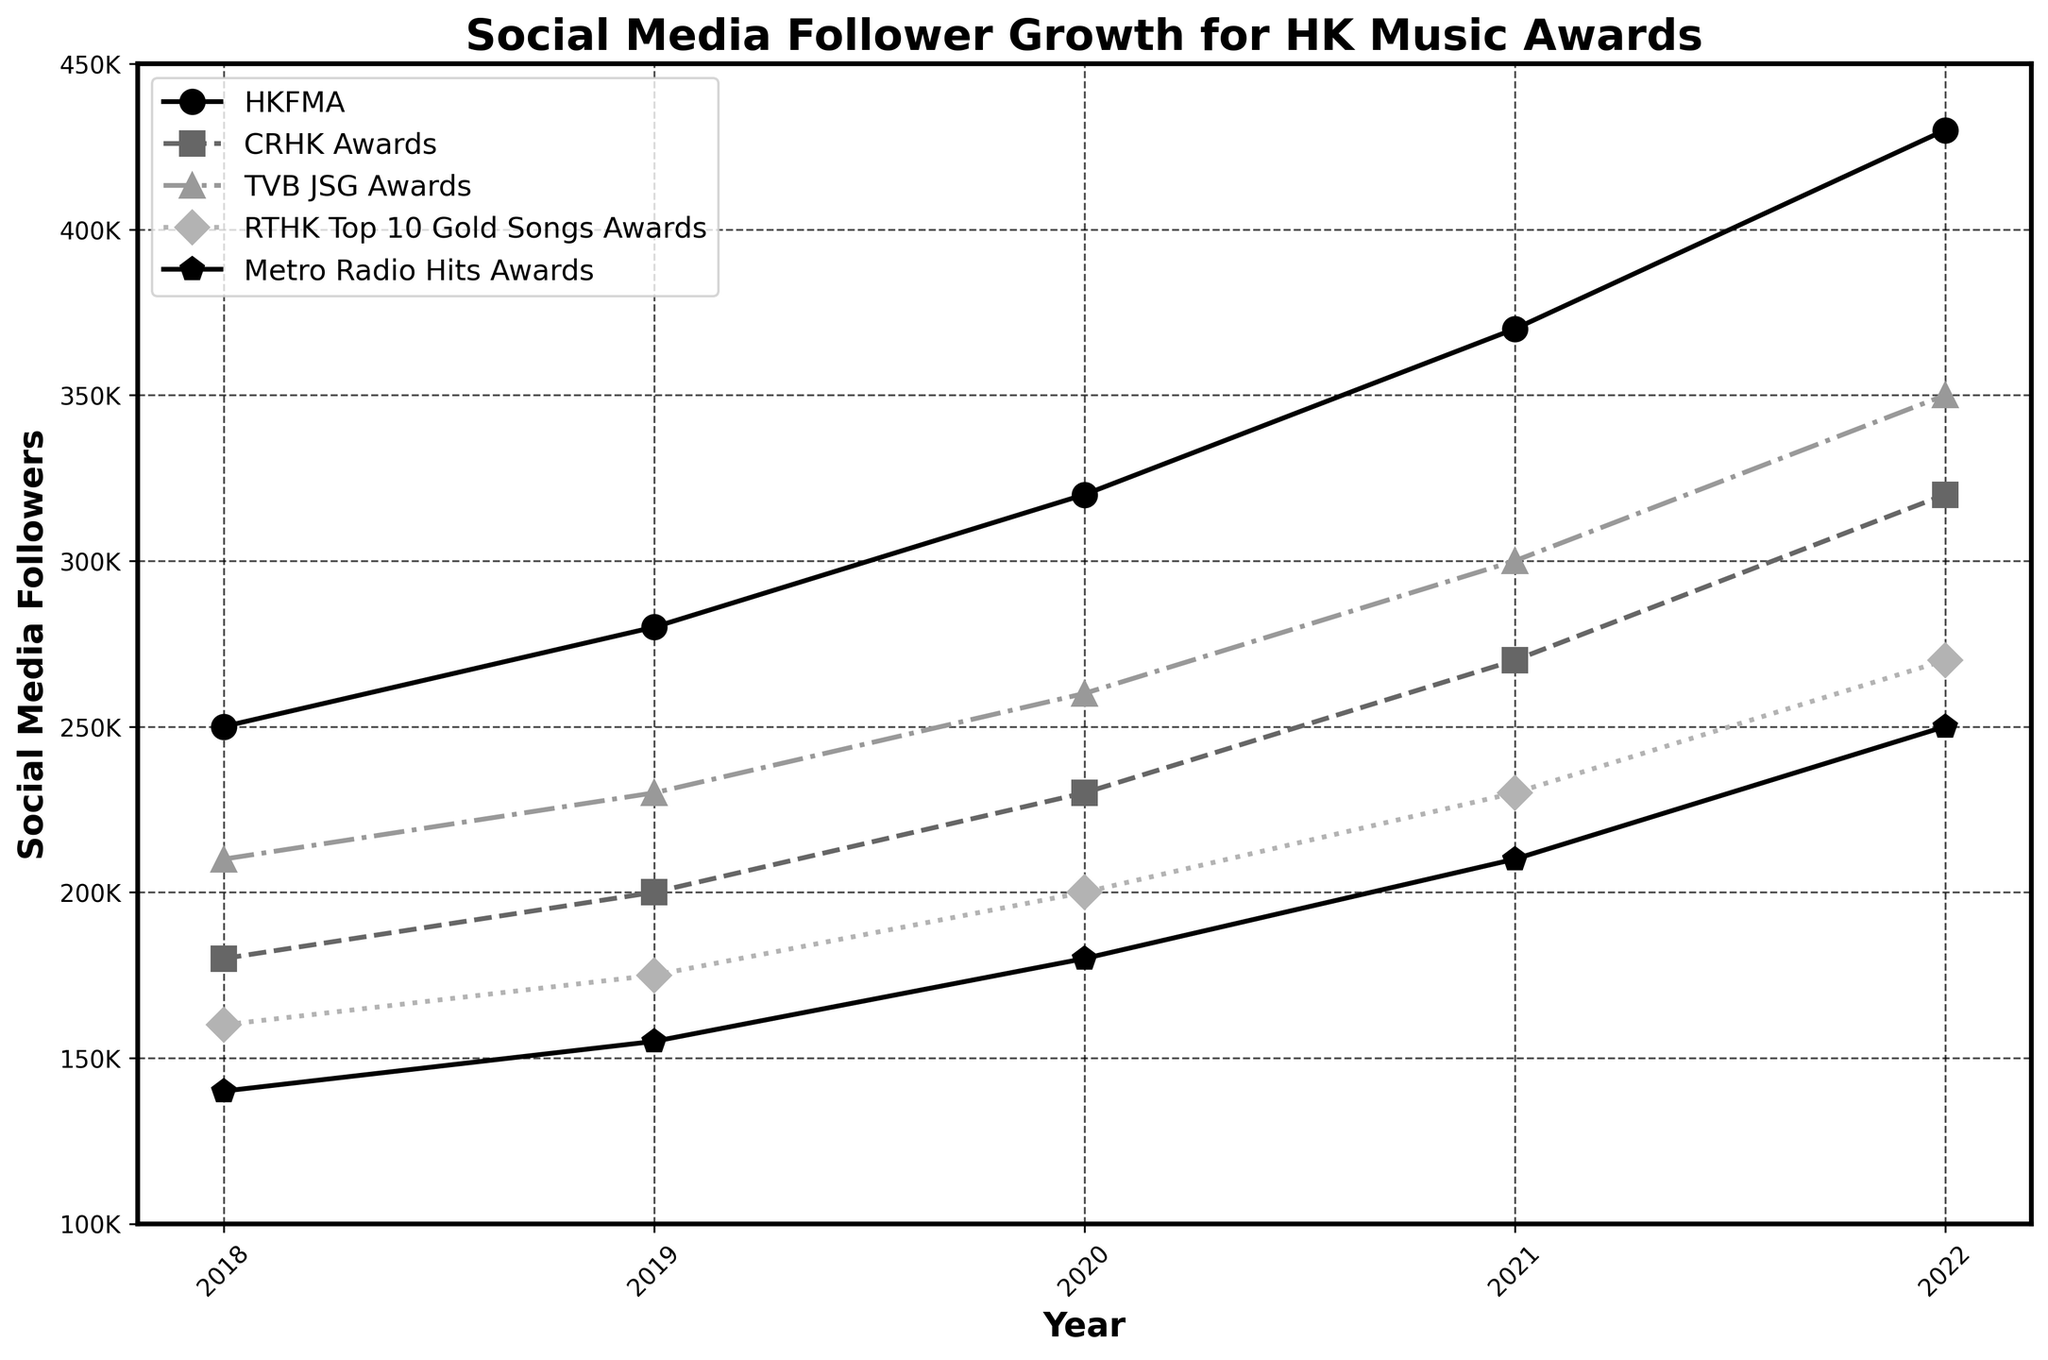Which music award show had the largest number of social media followers in 2021? Look at the 2021 data points on the graph and identify the highest line. The HKFMA had the highest follower count in 2021.
Answer: HKFMA Which award show saw the greatest increase in followers from 2018 to 2022? Calculate the difference in follower count from 2018 to 2022 for each award show. HKFMA increased by 430,000 - 250,000 = 180,000, CRHK Awards by 320,000 - 180,000 = 140,000, TVB JSG Awards by 350,000 - 210,000 = 140,000, RTHK Top 10 Gold Songs Awards by 270,000 - 160,000 = 110,000, and Metro Radio Hits Awards by 250,000 - 140,000 = 110,000. HKFMA had the largest increase.
Answer: HKFMA By how many followers did CRHK Awards surpass RTHK Top 10 Gold Songs Awards in 2022? Compare the follower counts for CRHK Awards and RTHK Top 10 Gold Songs Awards in 2022. CRHK Awards had 320,000 followers, and RTHK had 270,000. The difference is 320,000 - 270,000.
Answer: 50,000 What's the average annual increase in social media followers for TVB JSG Awards from 2018 to 2022? Calculate the annual increase for TVB JSG Awards: (350,000 - 210,000) / (2022 - 2018) = 140,000 / 4. The average increase per year is 35,000.
Answer: 35,000 Which two award shows had equal follower counts at any point, and in which year? Examine the lines to identify any intersection points. There are no intersections in the figure, so the follower counts are never equal at any point.
Answer: None Which award show had the smallest increase in followers from 2021 to 2022? Compute the increase for each award show from 2021 to 2022. HKFMA: 430,000 - 370,000 = 60,000, CRHK Awards: 320,000 - 270,000 = 50,000, TVB JSG Awards: 350,000 - 300,000 = 50,000, RTHK Top 10 Gold Songs: 270,000 - 230,000 = 40,000, Metro Radio Hits: 250,000 - 210,000 = 40,000. The smallest increases were RTHK Top 10 Gold Songs and Metro Radio Hits, both with 40,000.
Answer: RTHK Top 10 Gold Songs Awards, Metro Radio Hits Awards How many more followers did HKFMA have than Metro Radio Hits Awards in 2020? Compare the follower counts for HKFMA and Metro Radio Hits Awards in 2020. HKFMA had 320,000 followers, and Metro Radio Hits had 180,000. The difference is 320,000 - 180,000.
Answer: 140,000 